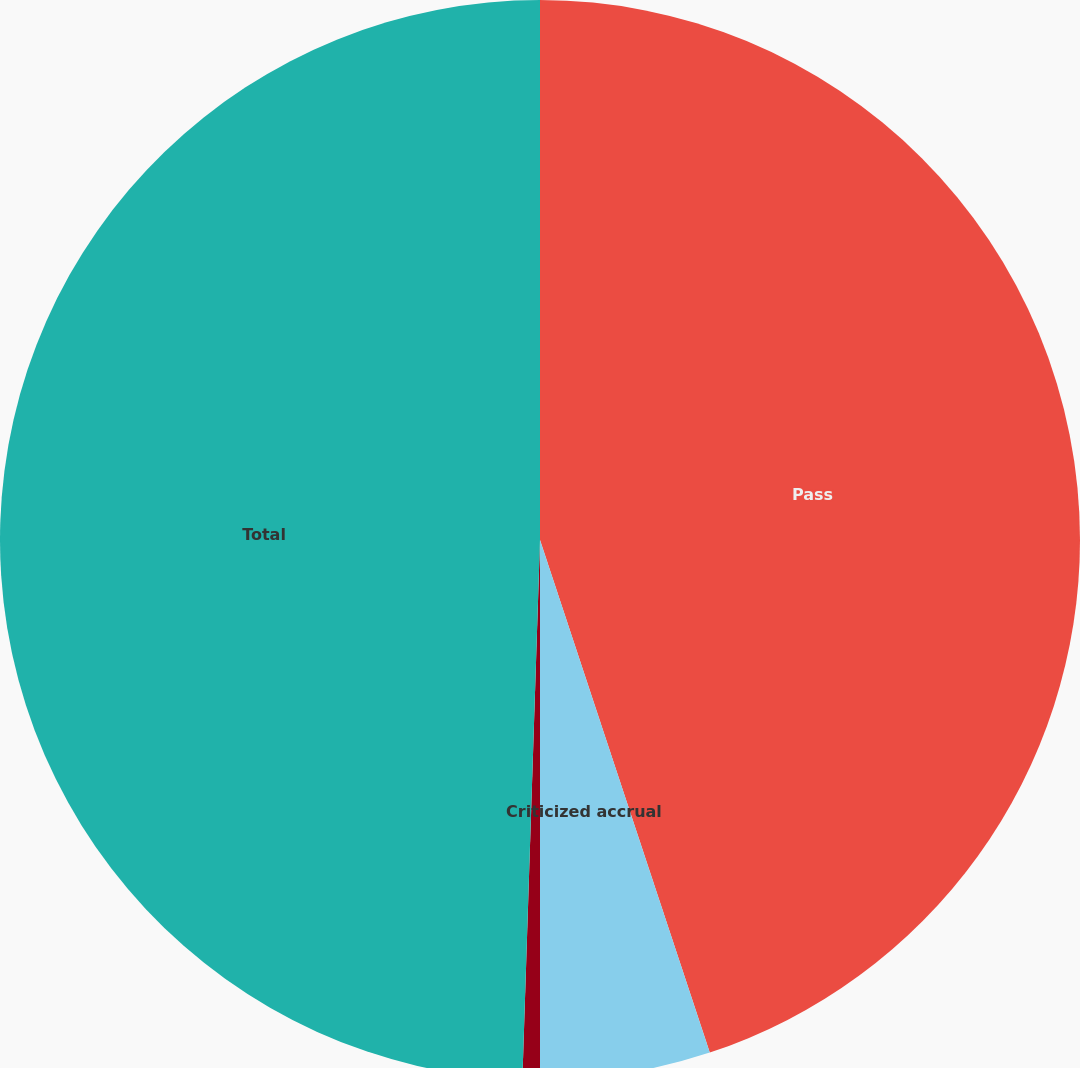Convert chart to OTSL. <chart><loc_0><loc_0><loc_500><loc_500><pie_chart><fcel>Pass<fcel>Criticized accrual<fcel>Criticized nonaccrual<fcel>Total<nl><fcel>44.91%<fcel>5.09%<fcel>0.52%<fcel>49.48%<nl></chart> 